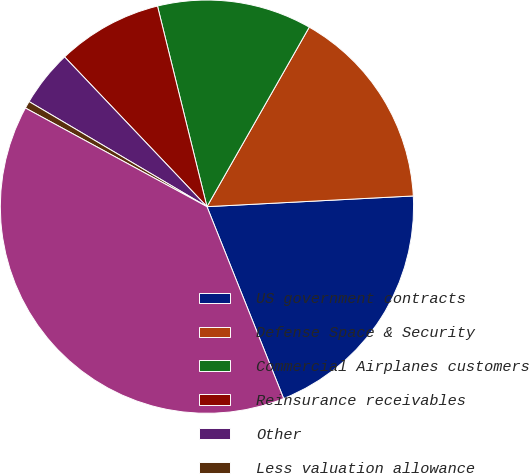Convert chart. <chart><loc_0><loc_0><loc_500><loc_500><pie_chart><fcel>US government contracts<fcel>Defense Space & Security<fcel>Commercial Airplanes customers<fcel>Reinsurance receivables<fcel>Other<fcel>Less valuation allowance<fcel>Total<nl><fcel>19.77%<fcel>15.93%<fcel>12.09%<fcel>8.25%<fcel>4.41%<fcel>0.57%<fcel>38.97%<nl></chart> 